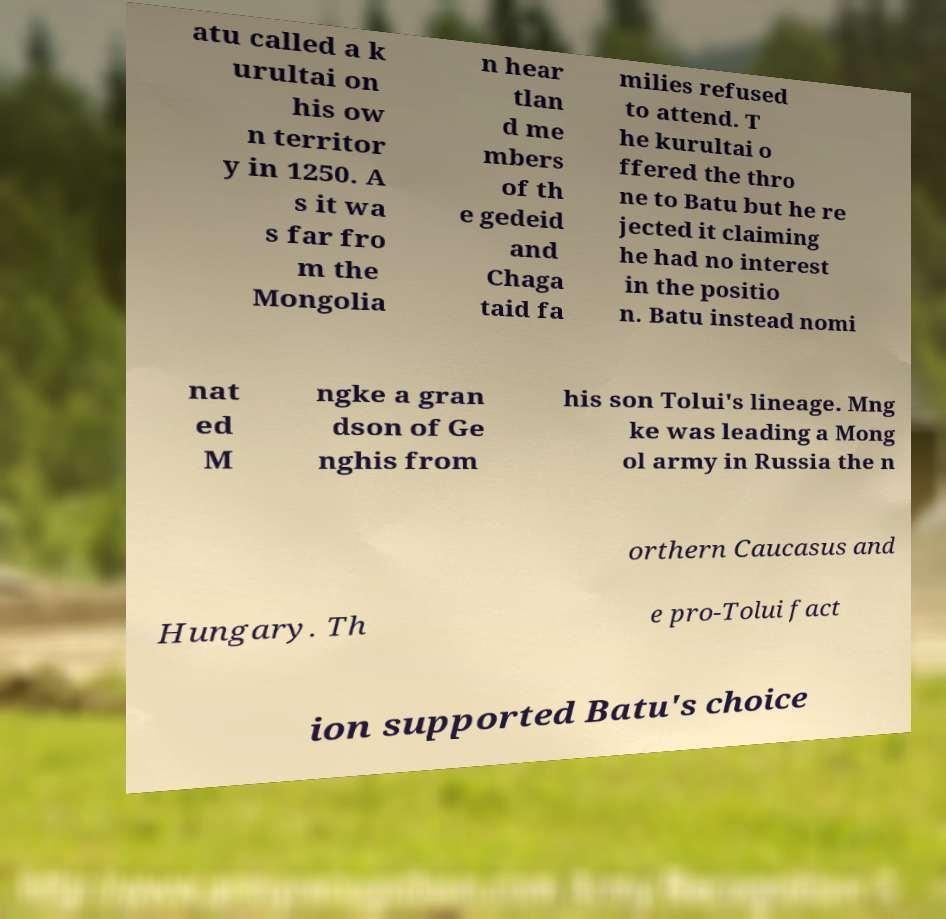What messages or text are displayed in this image? I need them in a readable, typed format. atu called a k urultai on his ow n territor y in 1250. A s it wa s far fro m the Mongolia n hear tlan d me mbers of th e gedeid and Chaga taid fa milies refused to attend. T he kurultai o ffered the thro ne to Batu but he re jected it claiming he had no interest in the positio n. Batu instead nomi nat ed M ngke a gran dson of Ge nghis from his son Tolui's lineage. Mng ke was leading a Mong ol army in Russia the n orthern Caucasus and Hungary. Th e pro-Tolui fact ion supported Batu's choice 